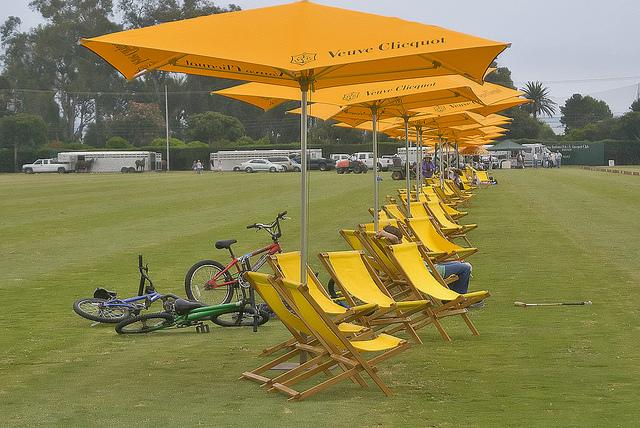The sporting event taking place on the grounds is most likely which one? polo 